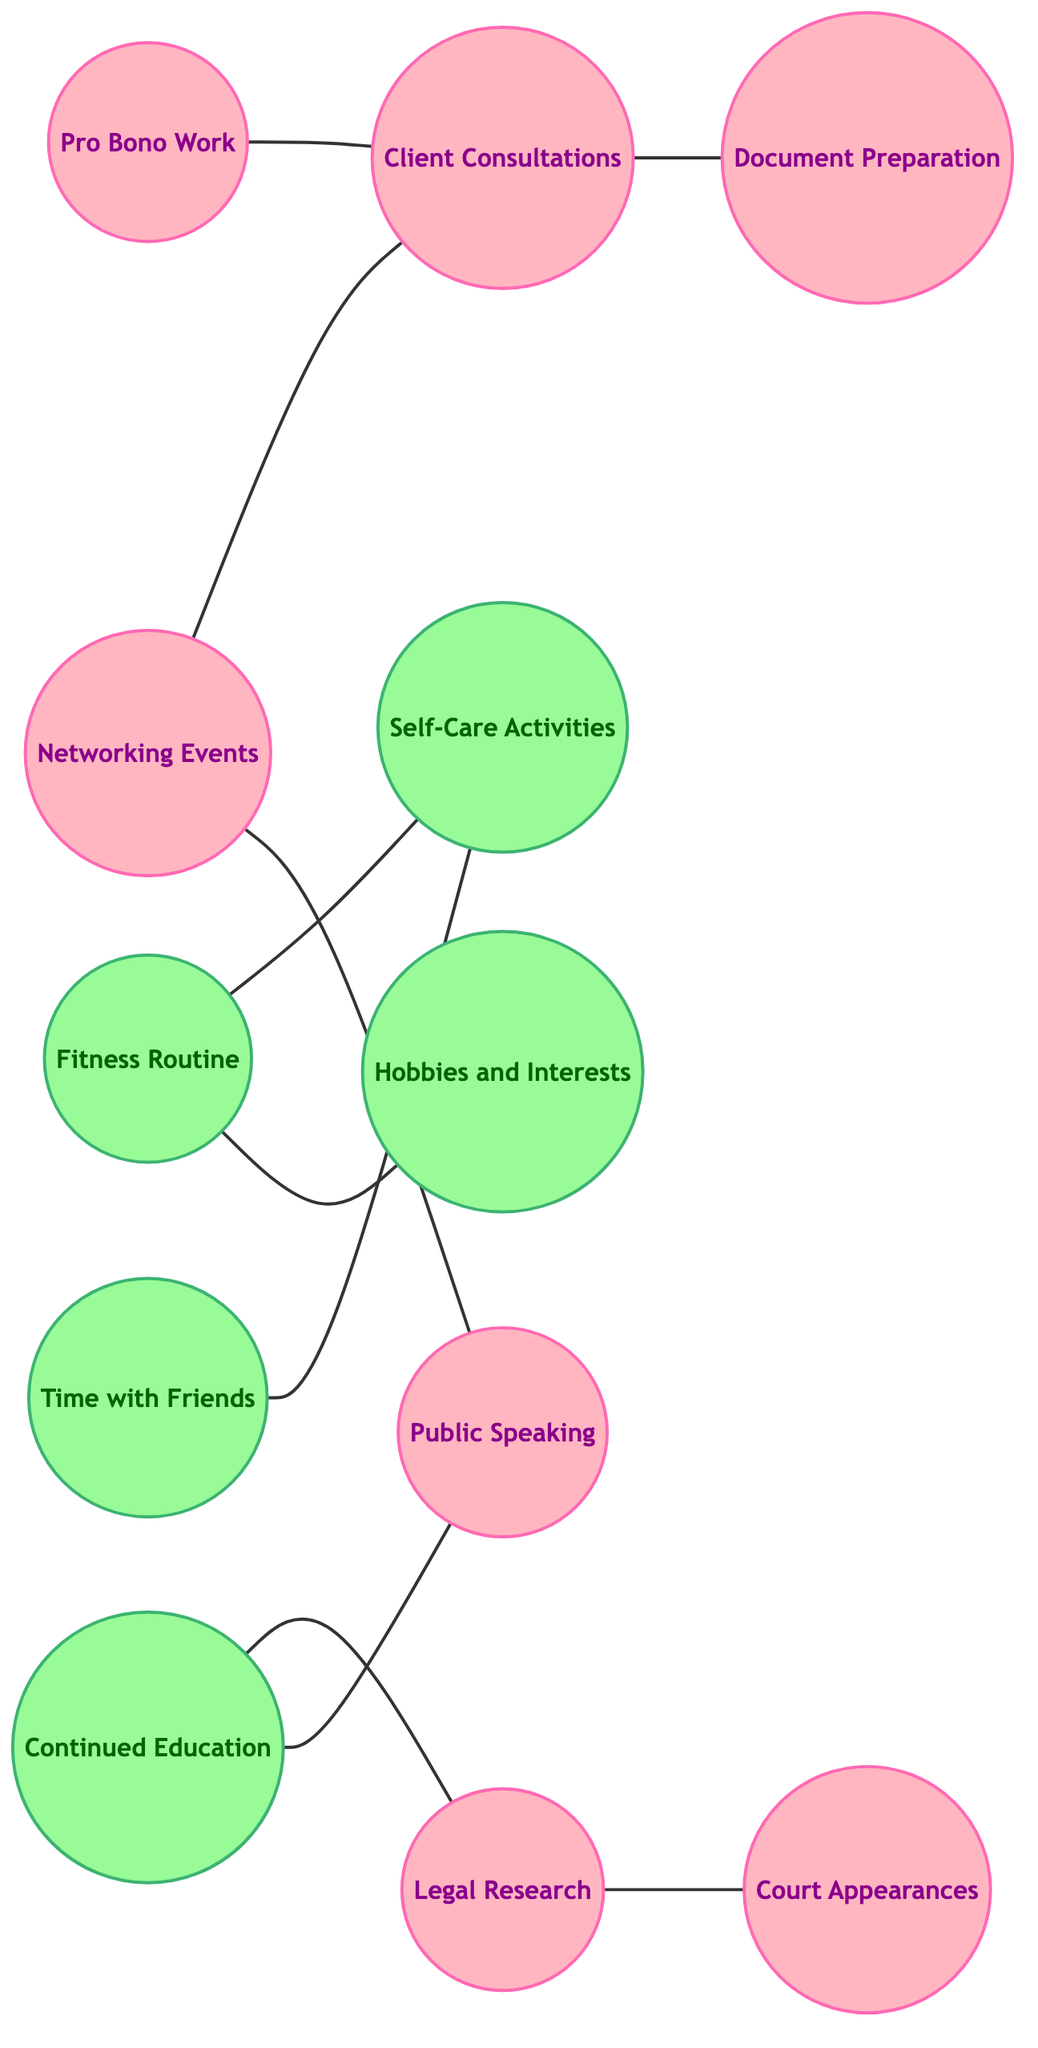What is the total number of nodes in the diagram? The diagram contains a list of nodes, which includes Legal Research, Court Appearances, Client Consultations, Document Preparation, Networking Events, Fitness Routine, Time with Friends, Self-Care Activities, Continued Education, Hobbies and Interests, Public Speaking, and Pro Bono Work. Counting these gives a total of 11 nodes.
Answer: 11 How many edges connect the nodes related to Client Consultations? By examining the diagram, the edges associated with Client Consultations are those connecting it to Document Preparation, Networking Events, and Pro Bono Work. This totals three connections.
Answer: 3 Which two nodes have a direct connection with Networking Events? The direct connections from Networking Events are to Client Consultations and Public Speaking, indicating these are the two nodes directly associated with it.
Answer: Client Consultations, Public Speaking What professional activity is linked to Legal Research? Legal Research is connected directly to Court Appearances according to the diagram, indicating that these two activities are related.
Answer: Court Appearances Which type of activities has more connections, professional or personal? On examining the connections, professional activities include connections to Court Appearances, Document Preparation, Client Consultations, Networking Events, Public Speaking, and Pro Bono Work, totaling six. Personal activities like Fitness Routine, Time with Friends, Self-Care Activities, Continued Education, and Hobbies and Interests exhibit five connections. So, professional activities have more connections.
Answer: Professional activities What personal activity connects with both Fitness Routine and Time with Friends? Self-Care Activities are the connecting node that links both Fitness Routine and Time with Friends. According to the diagram, this node indicates a shared personal activity associated with both.
Answer: Self-Care Activities Which node serves as a bridge between Continued Education and Legal Research? The connection from Continued Education to Legal Research is direct and establishes Continued Education as the bridge, showing its role in linking these two professional activities.
Answer: Continued Education Identify the node that is not connected to any other node in the diagram. Upon reviewing all the connections in the graph, there is no node that exists without a connection; hence, every node is interconnected, leading to no isolated points. Thus, none of the nodes are disconnected.
Answer: None 